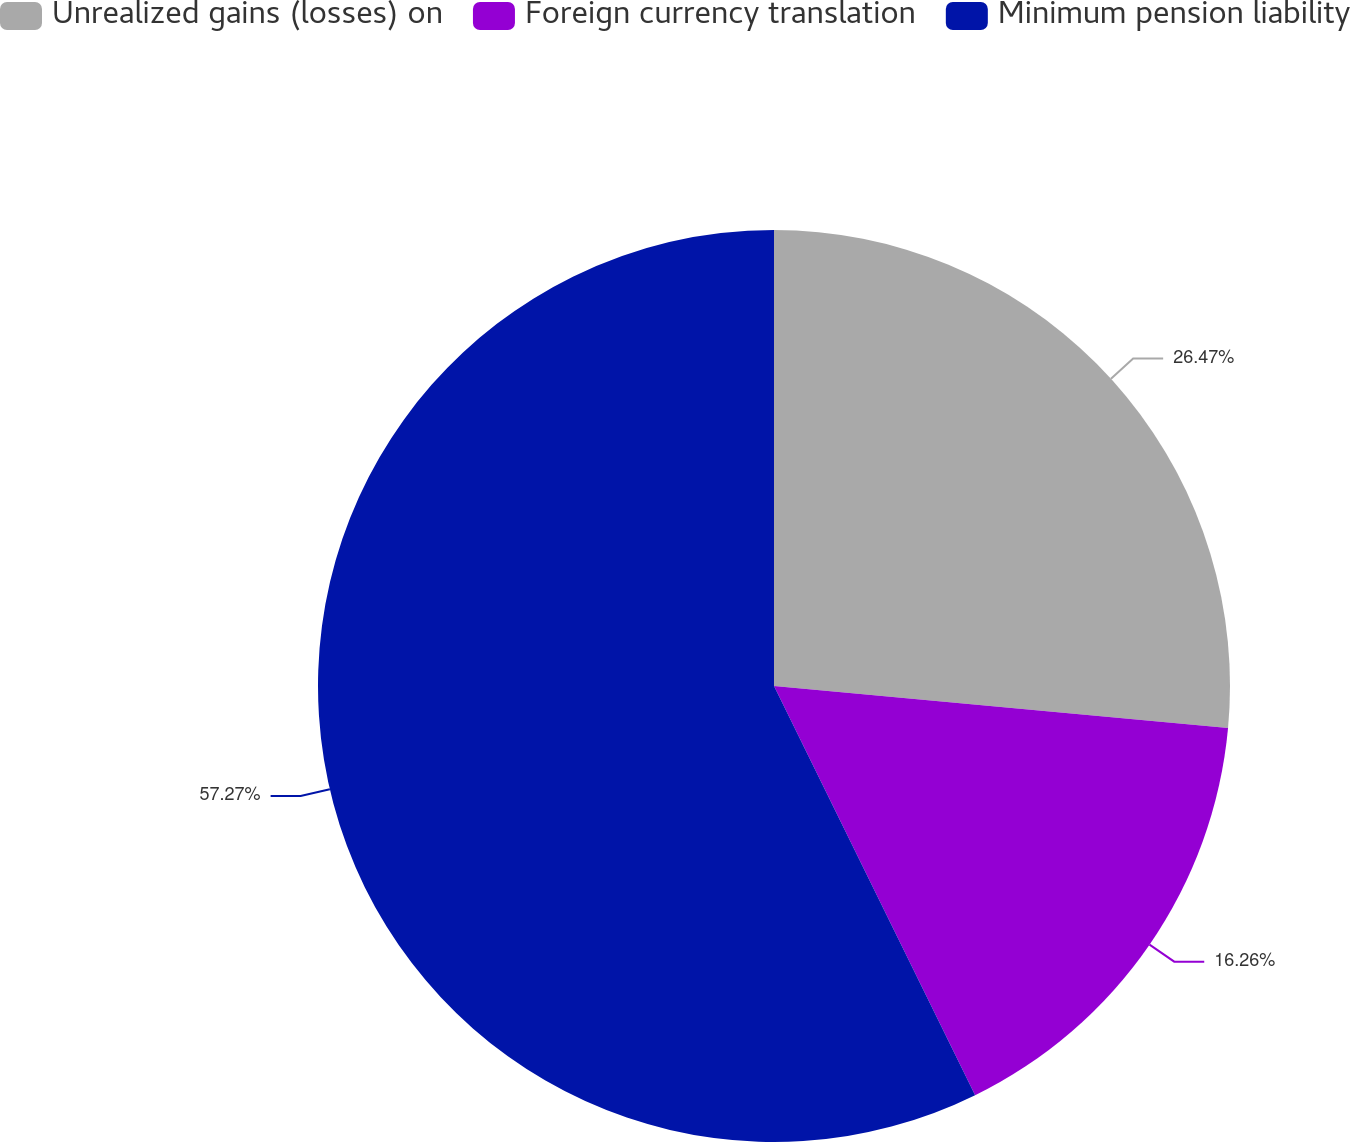Convert chart to OTSL. <chart><loc_0><loc_0><loc_500><loc_500><pie_chart><fcel>Unrealized gains (losses) on<fcel>Foreign currency translation<fcel>Minimum pension liability<nl><fcel>26.47%<fcel>16.26%<fcel>57.27%<nl></chart> 